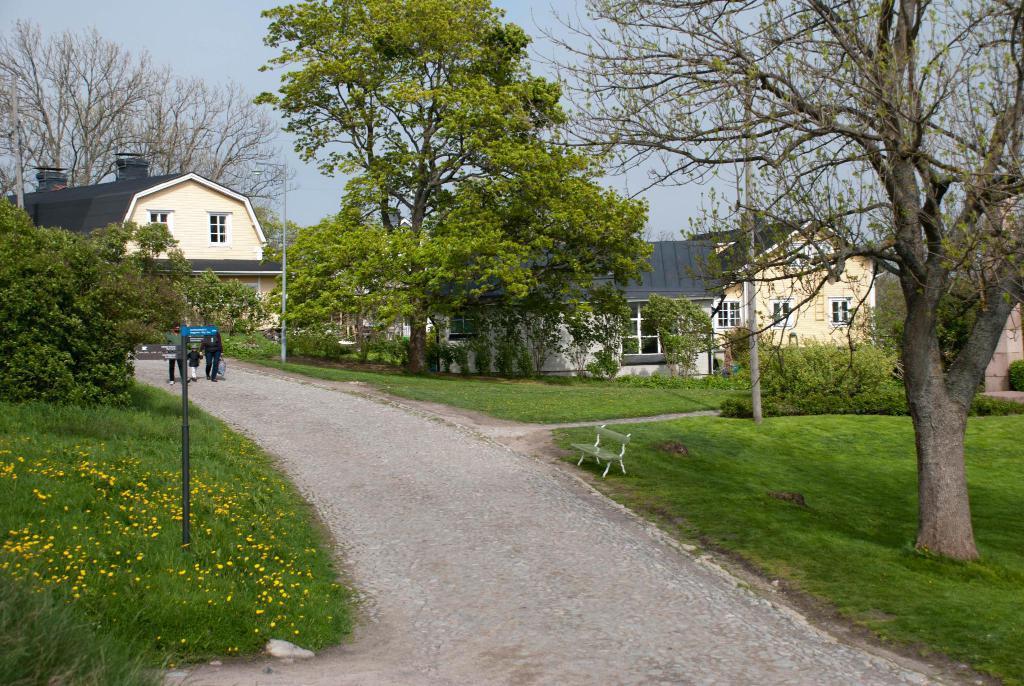Could you give a brief overview of what you see in this image? In this image I can see the road. To the side of the road I can see the yellow color flowers to the plants, pole, bench and many trees. I can see few people walking on the road. In the background there are houses with windows and the sky. 